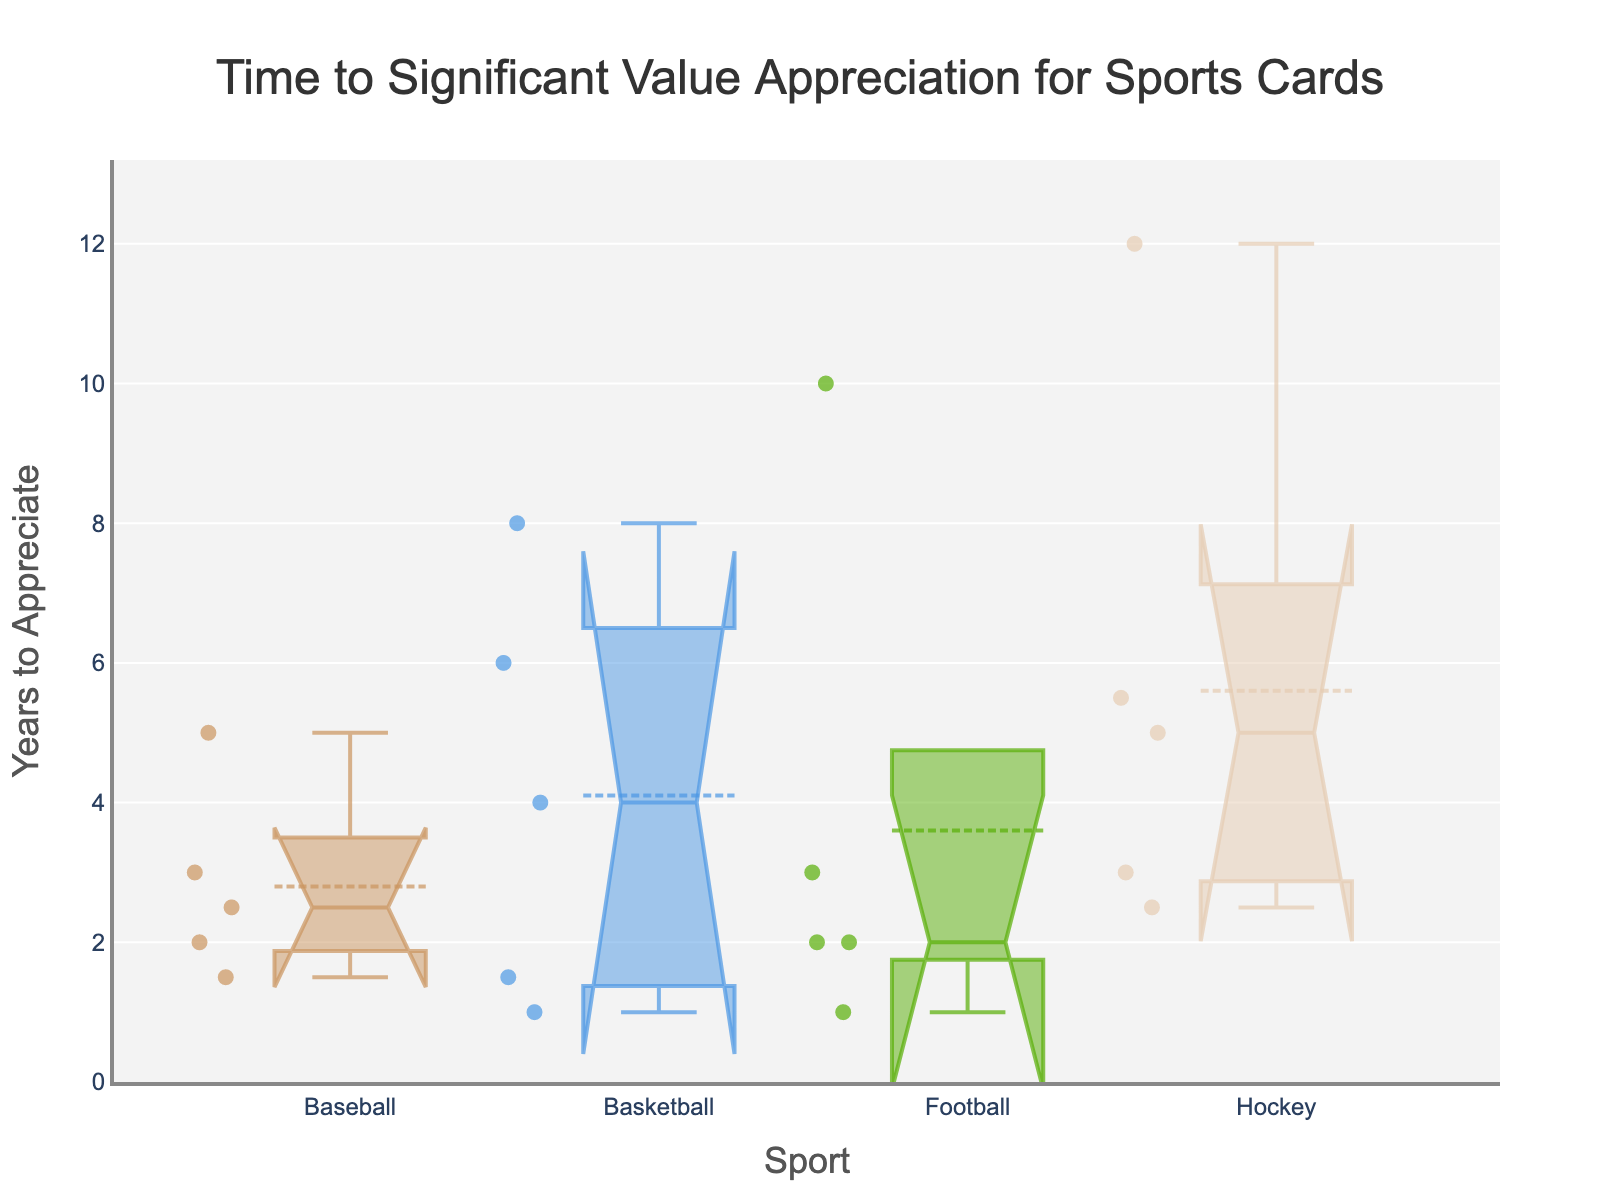What is the title of the figure? The title is usually located at the top center of the plot and is set to be descriptive of the data displayed.
Answer: Time to Significant Value Appreciation for Sports Cards How many sports are represented in the figure? To find out how many unique sports are present, you need to count the different categories on the x-axis.
Answer: 4 Which sport has the highest median number of years to appreciate? To determine this, look at the line inside the boxes that represents the median value for each sport. The highest median value will be the one where this line is the highest.
Answer: Hockey What is the approximate range of years for baseball cards to appreciate significantly? The range is indicated by the ends of the whiskers in the box plot for baseball. Estimate the lowest and highest points.
Answer: 1.5 to 5 years Which sport shows the widest range of appreciation times? Look at the length of the whiskers and the IQR (distance between the notches) for each sport. The sport with the largest range from the minimum to maximum values represents the widest range.
Answer: Hockey Which sport has the smallest median appreciation time for cards? Look at the box plot's median line for each sport. The smallest median will be the one closest to the bottom (y) axis.
Answer: Basketball Compare the median appreciation times between football and basketball. Which one is higher? Find the median lines within the boxes for both football and basketball. The sport with the median line located higher on the y-axis has the higher median appreciation time.
Answer: Football Are the appreciation times for basketball cards more consistent or more spread out compared to baseball cards? Compare the box lengths (interquartile range - IQR) and the lengths of the whiskers for both sports. If the box and whiskers are shorter for one sport, its appreciation times are more consistent.
Answer: More consistent Do any sports have overlapping notches in their box plots? If so, which ones? Overlapping notches suggest that there is no significant difference between those medians. Check the notches in the respective boxes for all sports.
Answer: Baseball and Basketball Which sport has cards with the maximum outlier years to appreciate? Outliers are represented as points outside the whiskers of the box plots. Identify the sport where one or more points are furthest from the whiskers.
Answer: Hockey 